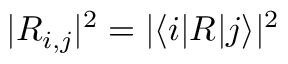Convert formula to latex. <formula><loc_0><loc_0><loc_500><loc_500>| R _ { i , j } | ^ { 2 } = | \langle i | R | j \rangle | ^ { 2 }</formula> 